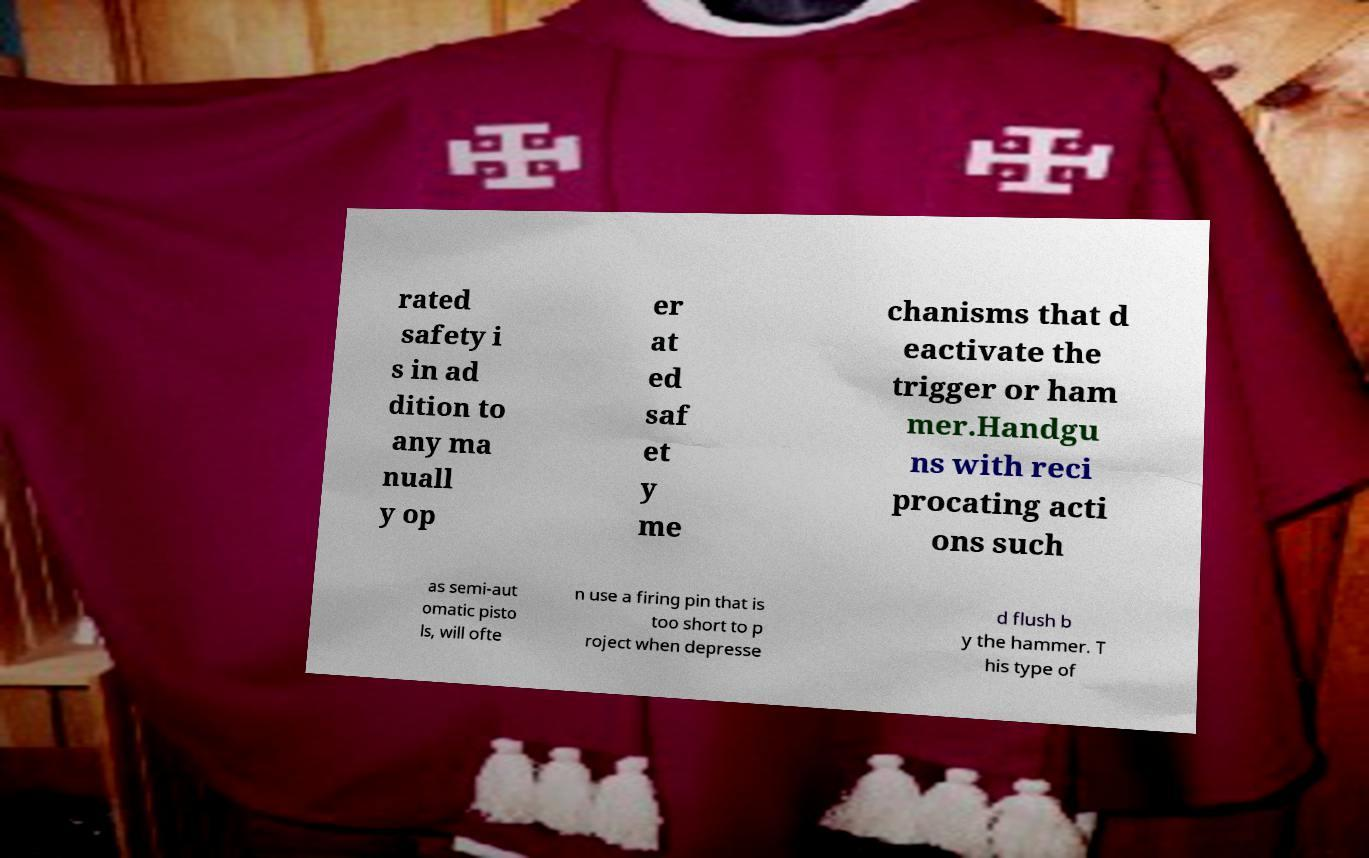Could you assist in decoding the text presented in this image and type it out clearly? rated safety i s in ad dition to any ma nuall y op er at ed saf et y me chanisms that d eactivate the trigger or ham mer.Handgu ns with reci procating acti ons such as semi-aut omatic pisto ls, will ofte n use a firing pin that is too short to p roject when depresse d flush b y the hammer. T his type of 